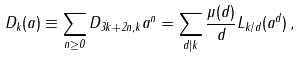<formula> <loc_0><loc_0><loc_500><loc_500>D _ { k } ( a ) \equiv \sum _ { n \geq 0 } D _ { 3 k + 2 n , k } a ^ { n } = \sum _ { d | k } \frac { \mu ( d ) } { d } L _ { k / d } ( a ^ { d } ) \, ,</formula> 